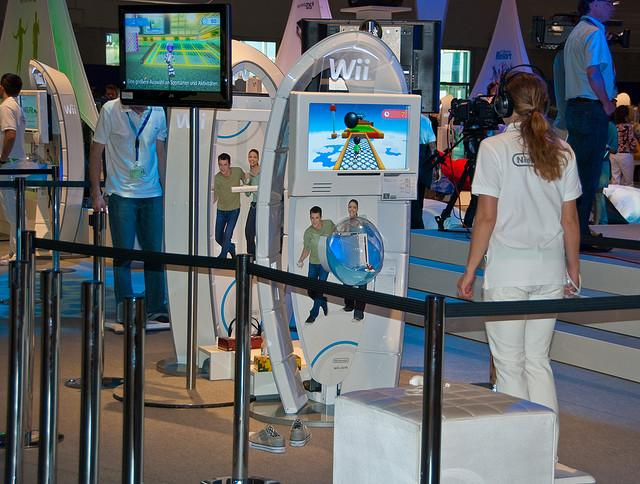What consumer electronic company made the white gaming displays?

Choices:
A) sega
B) sony
C) apple
D) nintendo nintendo 